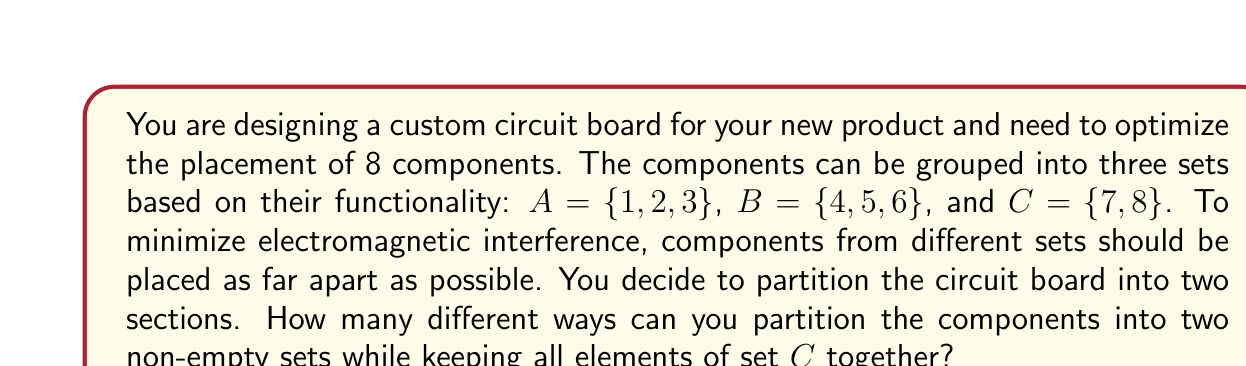Show me your answer to this math problem. Let's approach this step-by-step using set theory and partitioning principles:

1) First, we need to consider set C as a single unit since its elements must stay together. So, we effectively have 6 elements to partition: {1, 2, 3, 4, 5, 6, {7,8}}.

2) We can use the formula for the number of ways to partition n distinct objects into two non-empty sets:

   $$ S(n,2) = 2^{n-1} - 1 $$

   Where S(n,2) is the Stirling number of the second kind for n objects into 2 sets.

3) In our case, n = 6, so:

   $$ S(6,2) = 2^{6-1} - 1 = 2^5 - 1 = 32 - 1 = 31 $$

4) However, this counts all possible partitions. We need to consider the constraints from sets A and B.

5) Let's count the valid partitions:
   - C can be in either partition
   - For each placement of C, we need to distribute A and B elements

6) Cases:
   - C in first partition:
     * All of A in second, B split: 4 ways
     * All of B in second, A split: 4 ways
     * A and B both split: 3 * 3 = 9 ways
   - C in second partition: same as above

7) Total valid partitions:
   $$ (4 + 4 + 9) * 2 = 17 * 2 = 34 $$
Answer: 34 different ways 